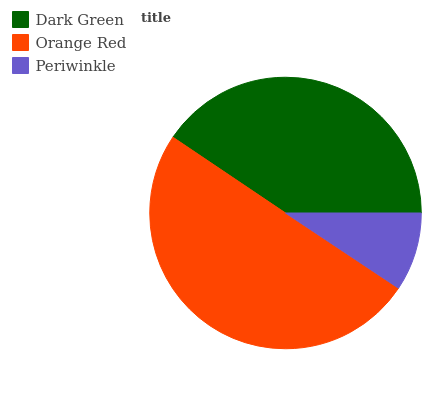Is Periwinkle the minimum?
Answer yes or no. Yes. Is Orange Red the maximum?
Answer yes or no. Yes. Is Orange Red the minimum?
Answer yes or no. No. Is Periwinkle the maximum?
Answer yes or no. No. Is Orange Red greater than Periwinkle?
Answer yes or no. Yes. Is Periwinkle less than Orange Red?
Answer yes or no. Yes. Is Periwinkle greater than Orange Red?
Answer yes or no. No. Is Orange Red less than Periwinkle?
Answer yes or no. No. Is Dark Green the high median?
Answer yes or no. Yes. Is Dark Green the low median?
Answer yes or no. Yes. Is Periwinkle the high median?
Answer yes or no. No. Is Orange Red the low median?
Answer yes or no. No. 